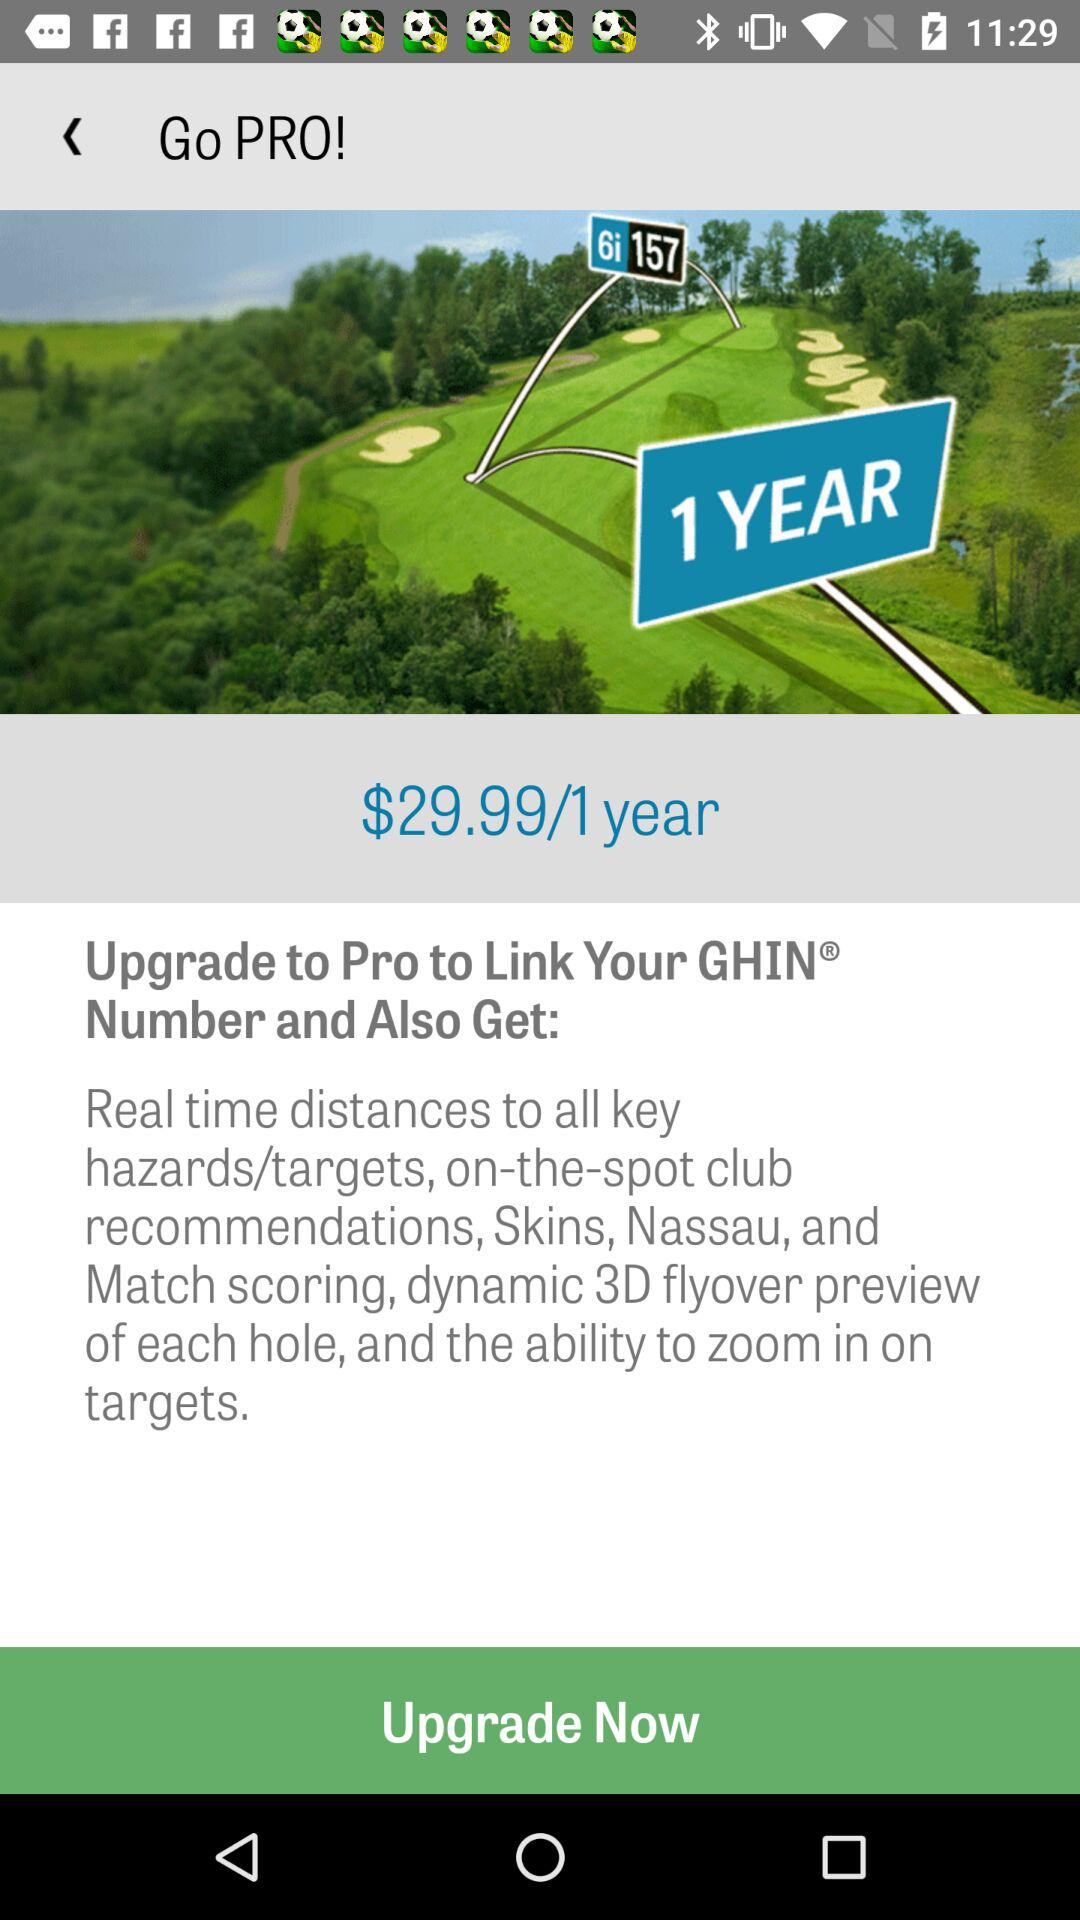What is the annual cost of upgrading to pro? The annual cost of upgrading to pro is $29.99. 